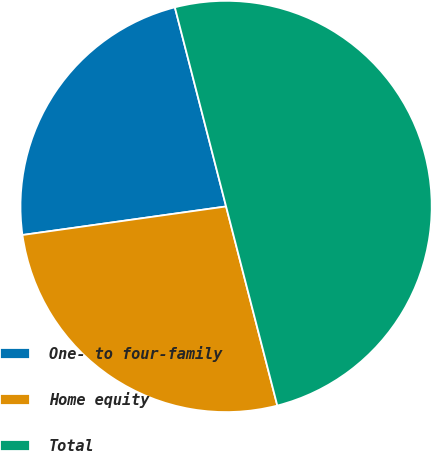Convert chart to OTSL. <chart><loc_0><loc_0><loc_500><loc_500><pie_chart><fcel>One- to four-family<fcel>Home equity<fcel>Total<nl><fcel>23.21%<fcel>26.79%<fcel>50.0%<nl></chart> 